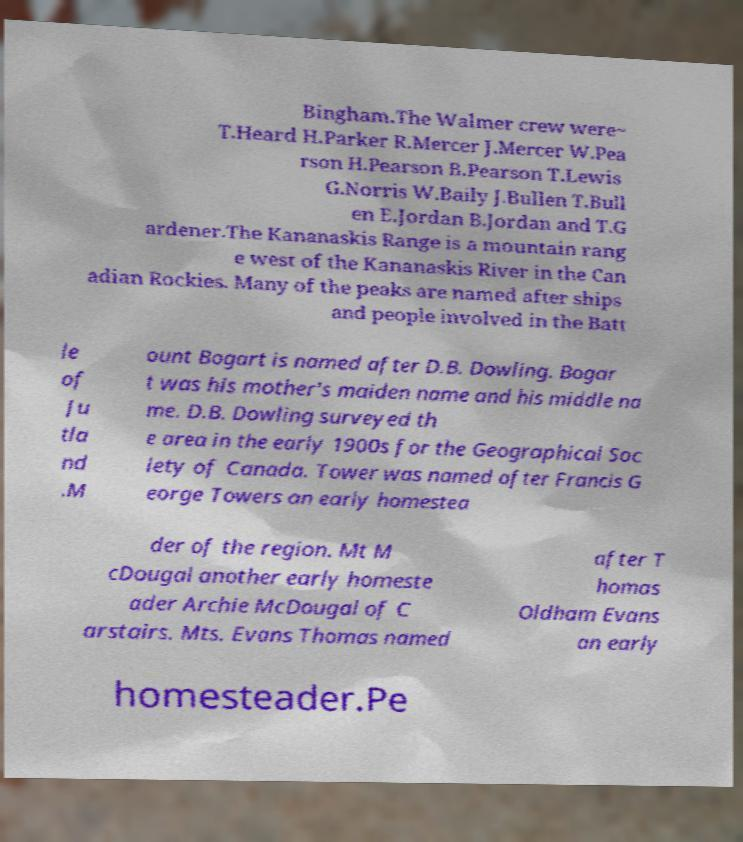There's text embedded in this image that I need extracted. Can you transcribe it verbatim? Bingham.The Walmer crew were~ T.Heard H.Parker R.Mercer J.Mercer W.Pea rson H.Pearson B.Pearson T.Lewis G.Norris W.Baily J.Bullen T.Bull en E.Jordan B.Jordan and T.G ardener.The Kananaskis Range is a mountain rang e west of the Kananaskis River in the Can adian Rockies. Many of the peaks are named after ships and people involved in the Batt le of Ju tla nd .M ount Bogart is named after D.B. Dowling. Bogar t was his mother's maiden name and his middle na me. D.B. Dowling surveyed th e area in the early 1900s for the Geographical Soc iety of Canada. Tower was named after Francis G eorge Towers an early homestea der of the region. Mt M cDougal another early homeste ader Archie McDougal of C arstairs. Mts. Evans Thomas named after T homas Oldham Evans an early homesteader.Pe 